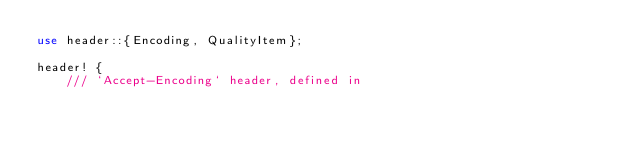<code> <loc_0><loc_0><loc_500><loc_500><_Rust_>use header::{Encoding, QualityItem};

header! {
    /// `Accept-Encoding` header, defined in</code> 